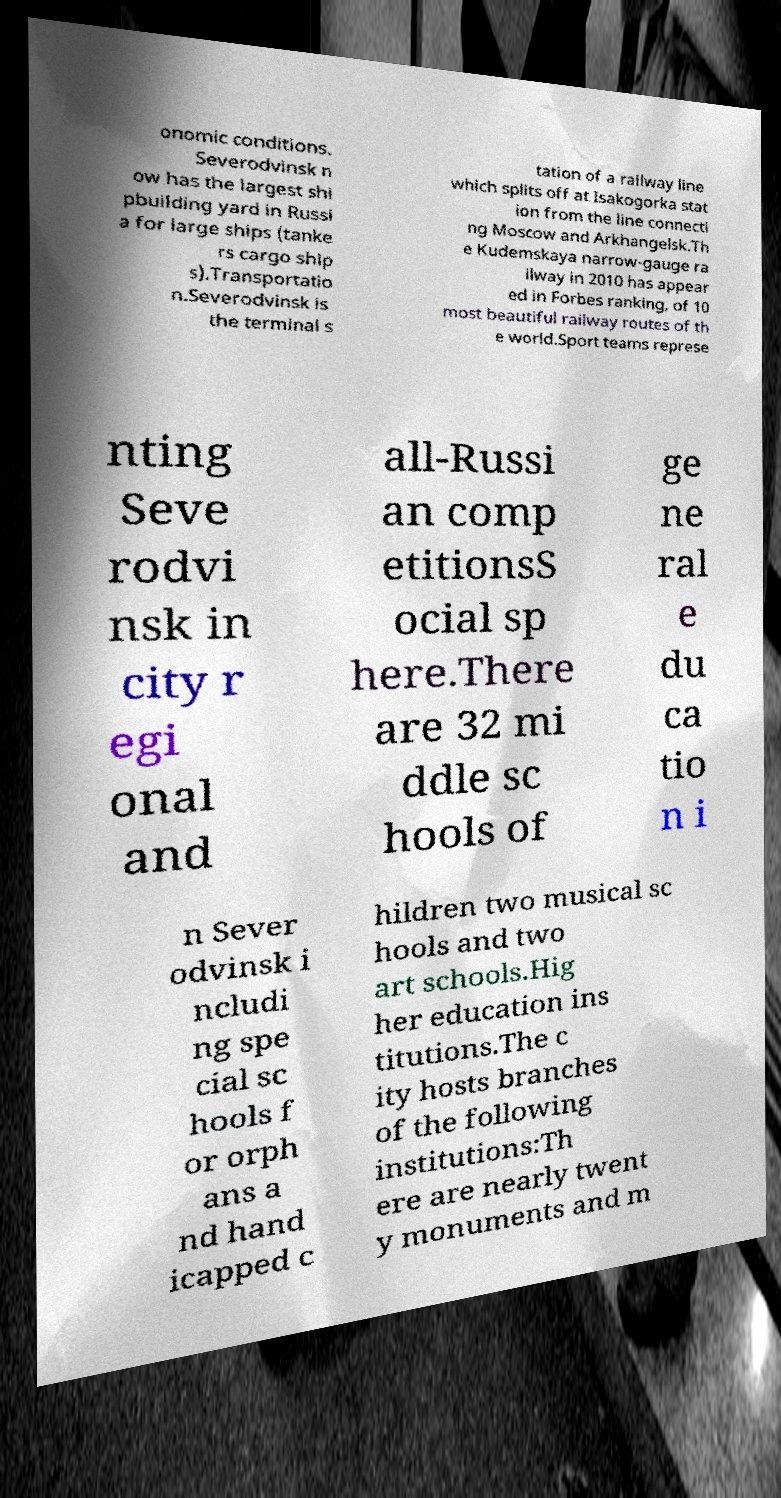Could you extract and type out the text from this image? onomic conditions. Severodvinsk n ow has the largest shi pbuilding yard in Russi a for large ships (tanke rs cargo ship s).Transportatio n.Severodvinsk is the terminal s tation of a railway line which splits off at Isakogorka stat ion from the line connecti ng Moscow and Arkhangelsk.Th e Kudemskaya narrow-gauge ra ilway in 2010 has appear ed in Forbes ranking, of 10 most beautiful railway routes of th e world.Sport teams represe nting Seve rodvi nsk in city r egi onal and all-Russi an comp etitionsS ocial sp here.There are 32 mi ddle sc hools of ge ne ral e du ca tio n i n Sever odvinsk i ncludi ng spe cial sc hools f or orph ans a nd hand icapped c hildren two musical sc hools and two art schools.Hig her education ins titutions.The c ity hosts branches of the following institutions:Th ere are nearly twent y monuments and m 